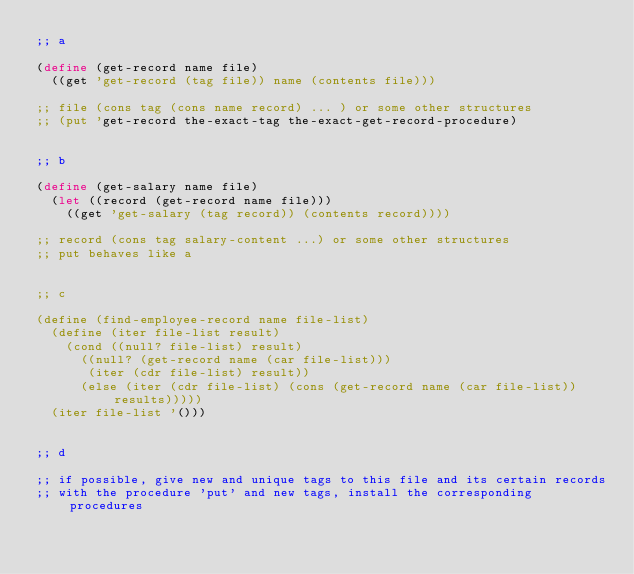Convert code to text. <code><loc_0><loc_0><loc_500><loc_500><_Scheme_>;; a

(define (get-record name file)
  ((get 'get-record (tag file)) name (contents file)))

;; file (cons tag (cons name record) ... ) or some other structures
;; (put 'get-record the-exact-tag the-exact-get-record-procedure)


;; b

(define (get-salary name file)
  (let ((record (get-record name file)))
    ((get 'get-salary (tag record)) (contents record))))

;; record (cons tag salary-content ...) or some other structures
;; put behaves like a


;; c

(define (find-employee-record name file-list)
  (define (iter file-list result)
    (cond ((null? file-list) result)
	  ((null? (get-record name (car file-list)))
	   (iter (cdr file-list) result))
	  (else (iter (cdr file-list) (cons (get-record name (car file-list)) results)))))
  (iter file-list '()))


;; d

;; if possible, give new and unique tags to this file and its certain records
;; with the procedure 'put' and new tags, install the corresponding procedures
</code> 